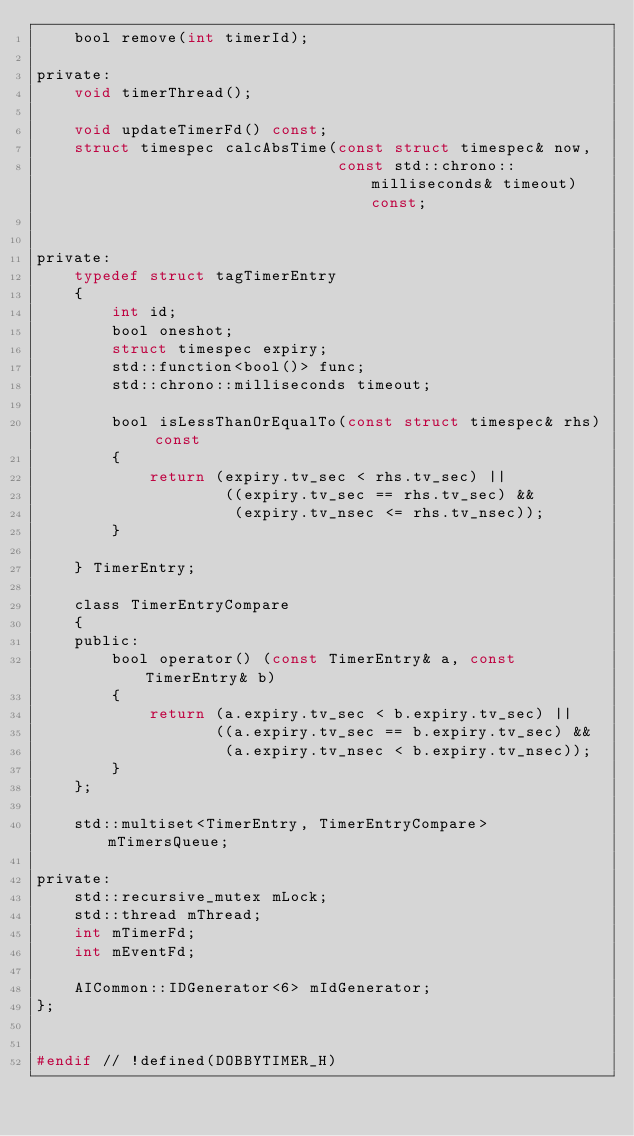Convert code to text. <code><loc_0><loc_0><loc_500><loc_500><_C_>    bool remove(int timerId);

private:
    void timerThread();

    void updateTimerFd() const;
    struct timespec calcAbsTime(const struct timespec& now,
                                const std::chrono::milliseconds& timeout) const;


private:
    typedef struct tagTimerEntry
    {
        int id;
        bool oneshot;
        struct timespec expiry;
        std::function<bool()> func;
        std::chrono::milliseconds timeout;

        bool isLessThanOrEqualTo(const struct timespec& rhs) const
        {
            return (expiry.tv_sec < rhs.tv_sec) ||
                    ((expiry.tv_sec == rhs.tv_sec) &&
                     (expiry.tv_nsec <= rhs.tv_nsec));
        }

    } TimerEntry;

    class TimerEntryCompare
    {
    public:
        bool operator() (const TimerEntry& a, const TimerEntry& b)
        {
            return (a.expiry.tv_sec < b.expiry.tv_sec) ||
                   ((a.expiry.tv_sec == b.expiry.tv_sec) &&
                    (a.expiry.tv_nsec < b.expiry.tv_nsec));
        }
    };

    std::multiset<TimerEntry, TimerEntryCompare> mTimersQueue;

private:
    std::recursive_mutex mLock;
    std::thread mThread;
    int mTimerFd;
    int mEventFd;

    AICommon::IDGenerator<6> mIdGenerator;
};


#endif // !defined(DOBBYTIMER_H)
</code> 